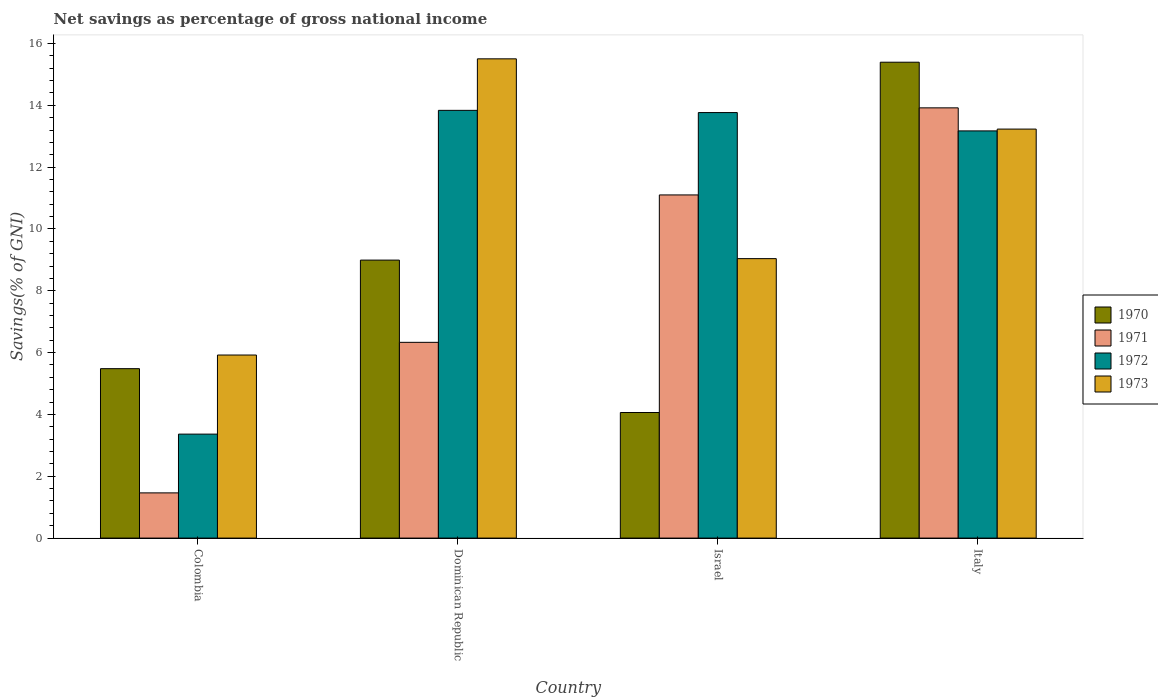How many different coloured bars are there?
Offer a terse response. 4. Are the number of bars per tick equal to the number of legend labels?
Provide a succinct answer. Yes. How many bars are there on the 2nd tick from the left?
Keep it short and to the point. 4. What is the total savings in 1973 in Israel?
Keep it short and to the point. 9.04. Across all countries, what is the maximum total savings in 1972?
Provide a succinct answer. 13.84. Across all countries, what is the minimum total savings in 1972?
Offer a very short reply. 3.36. In which country was the total savings in 1970 maximum?
Your answer should be very brief. Italy. What is the total total savings in 1970 in the graph?
Keep it short and to the point. 33.93. What is the difference between the total savings in 1973 in Colombia and that in Italy?
Make the answer very short. -7.31. What is the difference between the total savings in 1970 in Colombia and the total savings in 1972 in Italy?
Ensure brevity in your answer.  -7.69. What is the average total savings in 1972 per country?
Your answer should be compact. 11.04. What is the difference between the total savings of/in 1972 and total savings of/in 1973 in Dominican Republic?
Ensure brevity in your answer.  -1.67. What is the ratio of the total savings in 1972 in Colombia to that in Dominican Republic?
Keep it short and to the point. 0.24. Is the difference between the total savings in 1972 in Dominican Republic and Israel greater than the difference between the total savings in 1973 in Dominican Republic and Israel?
Your answer should be compact. No. What is the difference between the highest and the second highest total savings in 1970?
Offer a terse response. 3.51. What is the difference between the highest and the lowest total savings in 1970?
Ensure brevity in your answer.  11.33. In how many countries, is the total savings in 1972 greater than the average total savings in 1972 taken over all countries?
Give a very brief answer. 3. What does the 3rd bar from the left in Israel represents?
Your answer should be very brief. 1972. What does the 2nd bar from the right in Dominican Republic represents?
Offer a very short reply. 1972. Is it the case that in every country, the sum of the total savings in 1970 and total savings in 1971 is greater than the total savings in 1972?
Your answer should be compact. Yes. Are all the bars in the graph horizontal?
Offer a terse response. No. Are the values on the major ticks of Y-axis written in scientific E-notation?
Provide a short and direct response. No. Where does the legend appear in the graph?
Make the answer very short. Center right. How are the legend labels stacked?
Keep it short and to the point. Vertical. What is the title of the graph?
Keep it short and to the point. Net savings as percentage of gross national income. Does "2014" appear as one of the legend labels in the graph?
Your answer should be very brief. No. What is the label or title of the X-axis?
Give a very brief answer. Country. What is the label or title of the Y-axis?
Your answer should be compact. Savings(% of GNI). What is the Savings(% of GNI) of 1970 in Colombia?
Your answer should be very brief. 5.48. What is the Savings(% of GNI) in 1971 in Colombia?
Your response must be concise. 1.46. What is the Savings(% of GNI) in 1972 in Colombia?
Keep it short and to the point. 3.36. What is the Savings(% of GNI) in 1973 in Colombia?
Give a very brief answer. 5.92. What is the Savings(% of GNI) of 1970 in Dominican Republic?
Provide a short and direct response. 8.99. What is the Savings(% of GNI) of 1971 in Dominican Republic?
Your answer should be very brief. 6.33. What is the Savings(% of GNI) of 1972 in Dominican Republic?
Your answer should be compact. 13.84. What is the Savings(% of GNI) of 1973 in Dominican Republic?
Offer a very short reply. 15.5. What is the Savings(% of GNI) of 1970 in Israel?
Your answer should be compact. 4.06. What is the Savings(% of GNI) of 1971 in Israel?
Make the answer very short. 11.1. What is the Savings(% of GNI) in 1972 in Israel?
Ensure brevity in your answer.  13.77. What is the Savings(% of GNI) of 1973 in Israel?
Provide a succinct answer. 9.04. What is the Savings(% of GNI) in 1970 in Italy?
Keep it short and to the point. 15.4. What is the Savings(% of GNI) in 1971 in Italy?
Your answer should be compact. 13.92. What is the Savings(% of GNI) in 1972 in Italy?
Your answer should be compact. 13.17. What is the Savings(% of GNI) in 1973 in Italy?
Provide a succinct answer. 13.23. Across all countries, what is the maximum Savings(% of GNI) of 1970?
Ensure brevity in your answer.  15.4. Across all countries, what is the maximum Savings(% of GNI) of 1971?
Provide a short and direct response. 13.92. Across all countries, what is the maximum Savings(% of GNI) in 1972?
Provide a short and direct response. 13.84. Across all countries, what is the maximum Savings(% of GNI) in 1973?
Your answer should be compact. 15.5. Across all countries, what is the minimum Savings(% of GNI) of 1970?
Provide a short and direct response. 4.06. Across all countries, what is the minimum Savings(% of GNI) in 1971?
Provide a succinct answer. 1.46. Across all countries, what is the minimum Savings(% of GNI) in 1972?
Make the answer very short. 3.36. Across all countries, what is the minimum Savings(% of GNI) in 1973?
Ensure brevity in your answer.  5.92. What is the total Savings(% of GNI) of 1970 in the graph?
Provide a succinct answer. 33.93. What is the total Savings(% of GNI) of 1971 in the graph?
Keep it short and to the point. 32.82. What is the total Savings(% of GNI) in 1972 in the graph?
Your answer should be very brief. 44.14. What is the total Savings(% of GNI) of 1973 in the graph?
Your answer should be compact. 43.7. What is the difference between the Savings(% of GNI) in 1970 in Colombia and that in Dominican Republic?
Offer a very short reply. -3.51. What is the difference between the Savings(% of GNI) of 1971 in Colombia and that in Dominican Republic?
Your answer should be compact. -4.87. What is the difference between the Savings(% of GNI) in 1972 in Colombia and that in Dominican Republic?
Give a very brief answer. -10.47. What is the difference between the Savings(% of GNI) in 1973 in Colombia and that in Dominican Republic?
Your answer should be very brief. -9.58. What is the difference between the Savings(% of GNI) of 1970 in Colombia and that in Israel?
Your answer should be very brief. 1.42. What is the difference between the Savings(% of GNI) in 1971 in Colombia and that in Israel?
Give a very brief answer. -9.64. What is the difference between the Savings(% of GNI) of 1972 in Colombia and that in Israel?
Provide a succinct answer. -10.4. What is the difference between the Savings(% of GNI) in 1973 in Colombia and that in Israel?
Provide a short and direct response. -3.12. What is the difference between the Savings(% of GNI) of 1970 in Colombia and that in Italy?
Keep it short and to the point. -9.91. What is the difference between the Savings(% of GNI) of 1971 in Colombia and that in Italy?
Your answer should be very brief. -12.46. What is the difference between the Savings(% of GNI) of 1972 in Colombia and that in Italy?
Make the answer very short. -9.81. What is the difference between the Savings(% of GNI) in 1973 in Colombia and that in Italy?
Provide a short and direct response. -7.31. What is the difference between the Savings(% of GNI) of 1970 in Dominican Republic and that in Israel?
Ensure brevity in your answer.  4.93. What is the difference between the Savings(% of GNI) of 1971 in Dominican Republic and that in Israel?
Ensure brevity in your answer.  -4.77. What is the difference between the Savings(% of GNI) of 1972 in Dominican Republic and that in Israel?
Your response must be concise. 0.07. What is the difference between the Savings(% of GNI) in 1973 in Dominican Republic and that in Israel?
Ensure brevity in your answer.  6.46. What is the difference between the Savings(% of GNI) in 1970 in Dominican Republic and that in Italy?
Make the answer very short. -6.4. What is the difference between the Savings(% of GNI) of 1971 in Dominican Republic and that in Italy?
Offer a very short reply. -7.59. What is the difference between the Savings(% of GNI) of 1972 in Dominican Republic and that in Italy?
Keep it short and to the point. 0.66. What is the difference between the Savings(% of GNI) in 1973 in Dominican Republic and that in Italy?
Offer a very short reply. 2.27. What is the difference between the Savings(% of GNI) in 1970 in Israel and that in Italy?
Provide a succinct answer. -11.33. What is the difference between the Savings(% of GNI) of 1971 in Israel and that in Italy?
Offer a very short reply. -2.82. What is the difference between the Savings(% of GNI) in 1972 in Israel and that in Italy?
Make the answer very short. 0.59. What is the difference between the Savings(% of GNI) of 1973 in Israel and that in Italy?
Your response must be concise. -4.19. What is the difference between the Savings(% of GNI) in 1970 in Colombia and the Savings(% of GNI) in 1971 in Dominican Republic?
Provide a succinct answer. -0.85. What is the difference between the Savings(% of GNI) in 1970 in Colombia and the Savings(% of GNI) in 1972 in Dominican Republic?
Your answer should be compact. -8.36. What is the difference between the Savings(% of GNI) of 1970 in Colombia and the Savings(% of GNI) of 1973 in Dominican Republic?
Your answer should be very brief. -10.02. What is the difference between the Savings(% of GNI) of 1971 in Colombia and the Savings(% of GNI) of 1972 in Dominican Republic?
Give a very brief answer. -12.38. What is the difference between the Savings(% of GNI) of 1971 in Colombia and the Savings(% of GNI) of 1973 in Dominican Republic?
Offer a very short reply. -14.04. What is the difference between the Savings(% of GNI) of 1972 in Colombia and the Savings(% of GNI) of 1973 in Dominican Republic?
Ensure brevity in your answer.  -12.14. What is the difference between the Savings(% of GNI) in 1970 in Colombia and the Savings(% of GNI) in 1971 in Israel?
Ensure brevity in your answer.  -5.62. What is the difference between the Savings(% of GNI) in 1970 in Colombia and the Savings(% of GNI) in 1972 in Israel?
Your answer should be compact. -8.28. What is the difference between the Savings(% of GNI) in 1970 in Colombia and the Savings(% of GNI) in 1973 in Israel?
Ensure brevity in your answer.  -3.56. What is the difference between the Savings(% of GNI) of 1971 in Colombia and the Savings(% of GNI) of 1972 in Israel?
Keep it short and to the point. -12.3. What is the difference between the Savings(% of GNI) in 1971 in Colombia and the Savings(% of GNI) in 1973 in Israel?
Offer a very short reply. -7.58. What is the difference between the Savings(% of GNI) of 1972 in Colombia and the Savings(% of GNI) of 1973 in Israel?
Offer a terse response. -5.68. What is the difference between the Savings(% of GNI) in 1970 in Colombia and the Savings(% of GNI) in 1971 in Italy?
Your response must be concise. -8.44. What is the difference between the Savings(% of GNI) in 1970 in Colombia and the Savings(% of GNI) in 1972 in Italy?
Your answer should be compact. -7.69. What is the difference between the Savings(% of GNI) in 1970 in Colombia and the Savings(% of GNI) in 1973 in Italy?
Your answer should be very brief. -7.75. What is the difference between the Savings(% of GNI) of 1971 in Colombia and the Savings(% of GNI) of 1972 in Italy?
Give a very brief answer. -11.71. What is the difference between the Savings(% of GNI) of 1971 in Colombia and the Savings(% of GNI) of 1973 in Italy?
Ensure brevity in your answer.  -11.77. What is the difference between the Savings(% of GNI) in 1972 in Colombia and the Savings(% of GNI) in 1973 in Italy?
Give a very brief answer. -9.87. What is the difference between the Savings(% of GNI) in 1970 in Dominican Republic and the Savings(% of GNI) in 1971 in Israel?
Offer a terse response. -2.11. What is the difference between the Savings(% of GNI) of 1970 in Dominican Republic and the Savings(% of GNI) of 1972 in Israel?
Your answer should be compact. -4.77. What is the difference between the Savings(% of GNI) of 1970 in Dominican Republic and the Savings(% of GNI) of 1973 in Israel?
Offer a terse response. -0.05. What is the difference between the Savings(% of GNI) in 1971 in Dominican Republic and the Savings(% of GNI) in 1972 in Israel?
Make the answer very short. -7.43. What is the difference between the Savings(% of GNI) in 1971 in Dominican Republic and the Savings(% of GNI) in 1973 in Israel?
Ensure brevity in your answer.  -2.71. What is the difference between the Savings(% of GNI) of 1972 in Dominican Republic and the Savings(% of GNI) of 1973 in Israel?
Ensure brevity in your answer.  4.8. What is the difference between the Savings(% of GNI) of 1970 in Dominican Republic and the Savings(% of GNI) of 1971 in Italy?
Your answer should be very brief. -4.93. What is the difference between the Savings(% of GNI) of 1970 in Dominican Republic and the Savings(% of GNI) of 1972 in Italy?
Ensure brevity in your answer.  -4.18. What is the difference between the Savings(% of GNI) in 1970 in Dominican Republic and the Savings(% of GNI) in 1973 in Italy?
Provide a short and direct response. -4.24. What is the difference between the Savings(% of GNI) in 1971 in Dominican Republic and the Savings(% of GNI) in 1972 in Italy?
Offer a terse response. -6.84. What is the difference between the Savings(% of GNI) in 1971 in Dominican Republic and the Savings(% of GNI) in 1973 in Italy?
Offer a very short reply. -6.9. What is the difference between the Savings(% of GNI) in 1972 in Dominican Republic and the Savings(% of GNI) in 1973 in Italy?
Your answer should be compact. 0.61. What is the difference between the Savings(% of GNI) of 1970 in Israel and the Savings(% of GNI) of 1971 in Italy?
Give a very brief answer. -9.86. What is the difference between the Savings(% of GNI) of 1970 in Israel and the Savings(% of GNI) of 1972 in Italy?
Give a very brief answer. -9.11. What is the difference between the Savings(% of GNI) of 1970 in Israel and the Savings(% of GNI) of 1973 in Italy?
Your response must be concise. -9.17. What is the difference between the Savings(% of GNI) in 1971 in Israel and the Savings(% of GNI) in 1972 in Italy?
Keep it short and to the point. -2.07. What is the difference between the Savings(% of GNI) of 1971 in Israel and the Savings(% of GNI) of 1973 in Italy?
Offer a terse response. -2.13. What is the difference between the Savings(% of GNI) of 1972 in Israel and the Savings(% of GNI) of 1973 in Italy?
Keep it short and to the point. 0.53. What is the average Savings(% of GNI) in 1970 per country?
Provide a succinct answer. 8.48. What is the average Savings(% of GNI) of 1971 per country?
Your answer should be compact. 8.2. What is the average Savings(% of GNI) in 1972 per country?
Offer a terse response. 11.04. What is the average Savings(% of GNI) of 1973 per country?
Offer a very short reply. 10.93. What is the difference between the Savings(% of GNI) of 1970 and Savings(% of GNI) of 1971 in Colombia?
Ensure brevity in your answer.  4.02. What is the difference between the Savings(% of GNI) of 1970 and Savings(% of GNI) of 1972 in Colombia?
Your answer should be very brief. 2.12. What is the difference between the Savings(% of GNI) in 1970 and Savings(% of GNI) in 1973 in Colombia?
Give a very brief answer. -0.44. What is the difference between the Savings(% of GNI) of 1971 and Savings(% of GNI) of 1972 in Colombia?
Make the answer very short. -1.9. What is the difference between the Savings(% of GNI) in 1971 and Savings(% of GNI) in 1973 in Colombia?
Your answer should be compact. -4.46. What is the difference between the Savings(% of GNI) in 1972 and Savings(% of GNI) in 1973 in Colombia?
Offer a terse response. -2.56. What is the difference between the Savings(% of GNI) in 1970 and Savings(% of GNI) in 1971 in Dominican Republic?
Provide a succinct answer. 2.66. What is the difference between the Savings(% of GNI) of 1970 and Savings(% of GNI) of 1972 in Dominican Republic?
Keep it short and to the point. -4.84. What is the difference between the Savings(% of GNI) in 1970 and Savings(% of GNI) in 1973 in Dominican Republic?
Your answer should be compact. -6.51. What is the difference between the Savings(% of GNI) of 1971 and Savings(% of GNI) of 1972 in Dominican Republic?
Provide a short and direct response. -7.5. What is the difference between the Savings(% of GNI) in 1971 and Savings(% of GNI) in 1973 in Dominican Republic?
Make the answer very short. -9.17. What is the difference between the Savings(% of GNI) in 1972 and Savings(% of GNI) in 1973 in Dominican Republic?
Ensure brevity in your answer.  -1.67. What is the difference between the Savings(% of GNI) in 1970 and Savings(% of GNI) in 1971 in Israel?
Provide a succinct answer. -7.04. What is the difference between the Savings(% of GNI) in 1970 and Savings(% of GNI) in 1972 in Israel?
Offer a terse response. -9.7. What is the difference between the Savings(% of GNI) in 1970 and Savings(% of GNI) in 1973 in Israel?
Provide a short and direct response. -4.98. What is the difference between the Savings(% of GNI) of 1971 and Savings(% of GNI) of 1972 in Israel?
Provide a short and direct response. -2.66. What is the difference between the Savings(% of GNI) of 1971 and Savings(% of GNI) of 1973 in Israel?
Keep it short and to the point. 2.06. What is the difference between the Savings(% of GNI) in 1972 and Savings(% of GNI) in 1973 in Israel?
Give a very brief answer. 4.73. What is the difference between the Savings(% of GNI) in 1970 and Savings(% of GNI) in 1971 in Italy?
Your response must be concise. 1.48. What is the difference between the Savings(% of GNI) in 1970 and Savings(% of GNI) in 1972 in Italy?
Your response must be concise. 2.22. What is the difference between the Savings(% of GNI) of 1970 and Savings(% of GNI) of 1973 in Italy?
Offer a terse response. 2.16. What is the difference between the Savings(% of GNI) of 1971 and Savings(% of GNI) of 1972 in Italy?
Your answer should be very brief. 0.75. What is the difference between the Savings(% of GNI) of 1971 and Savings(% of GNI) of 1973 in Italy?
Provide a short and direct response. 0.69. What is the difference between the Savings(% of GNI) of 1972 and Savings(% of GNI) of 1973 in Italy?
Keep it short and to the point. -0.06. What is the ratio of the Savings(% of GNI) in 1970 in Colombia to that in Dominican Republic?
Your answer should be very brief. 0.61. What is the ratio of the Savings(% of GNI) in 1971 in Colombia to that in Dominican Republic?
Your response must be concise. 0.23. What is the ratio of the Savings(% of GNI) of 1972 in Colombia to that in Dominican Republic?
Keep it short and to the point. 0.24. What is the ratio of the Savings(% of GNI) of 1973 in Colombia to that in Dominican Republic?
Give a very brief answer. 0.38. What is the ratio of the Savings(% of GNI) in 1970 in Colombia to that in Israel?
Provide a short and direct response. 1.35. What is the ratio of the Savings(% of GNI) in 1971 in Colombia to that in Israel?
Your response must be concise. 0.13. What is the ratio of the Savings(% of GNI) in 1972 in Colombia to that in Israel?
Keep it short and to the point. 0.24. What is the ratio of the Savings(% of GNI) of 1973 in Colombia to that in Israel?
Make the answer very short. 0.66. What is the ratio of the Savings(% of GNI) of 1970 in Colombia to that in Italy?
Your answer should be very brief. 0.36. What is the ratio of the Savings(% of GNI) of 1971 in Colombia to that in Italy?
Your response must be concise. 0.11. What is the ratio of the Savings(% of GNI) of 1972 in Colombia to that in Italy?
Your response must be concise. 0.26. What is the ratio of the Savings(% of GNI) in 1973 in Colombia to that in Italy?
Your answer should be very brief. 0.45. What is the ratio of the Savings(% of GNI) in 1970 in Dominican Republic to that in Israel?
Offer a very short reply. 2.21. What is the ratio of the Savings(% of GNI) of 1971 in Dominican Republic to that in Israel?
Your response must be concise. 0.57. What is the ratio of the Savings(% of GNI) in 1972 in Dominican Republic to that in Israel?
Your answer should be very brief. 1.01. What is the ratio of the Savings(% of GNI) in 1973 in Dominican Republic to that in Israel?
Your response must be concise. 1.71. What is the ratio of the Savings(% of GNI) of 1970 in Dominican Republic to that in Italy?
Keep it short and to the point. 0.58. What is the ratio of the Savings(% of GNI) in 1971 in Dominican Republic to that in Italy?
Your answer should be very brief. 0.46. What is the ratio of the Savings(% of GNI) in 1972 in Dominican Republic to that in Italy?
Keep it short and to the point. 1.05. What is the ratio of the Savings(% of GNI) of 1973 in Dominican Republic to that in Italy?
Provide a short and direct response. 1.17. What is the ratio of the Savings(% of GNI) in 1970 in Israel to that in Italy?
Your answer should be compact. 0.26. What is the ratio of the Savings(% of GNI) in 1971 in Israel to that in Italy?
Your response must be concise. 0.8. What is the ratio of the Savings(% of GNI) of 1972 in Israel to that in Italy?
Ensure brevity in your answer.  1.04. What is the ratio of the Savings(% of GNI) in 1973 in Israel to that in Italy?
Your answer should be compact. 0.68. What is the difference between the highest and the second highest Savings(% of GNI) in 1970?
Your answer should be very brief. 6.4. What is the difference between the highest and the second highest Savings(% of GNI) in 1971?
Your answer should be compact. 2.82. What is the difference between the highest and the second highest Savings(% of GNI) in 1972?
Your answer should be very brief. 0.07. What is the difference between the highest and the second highest Savings(% of GNI) in 1973?
Your answer should be very brief. 2.27. What is the difference between the highest and the lowest Savings(% of GNI) in 1970?
Your answer should be compact. 11.33. What is the difference between the highest and the lowest Savings(% of GNI) in 1971?
Offer a terse response. 12.46. What is the difference between the highest and the lowest Savings(% of GNI) of 1972?
Offer a very short reply. 10.47. What is the difference between the highest and the lowest Savings(% of GNI) in 1973?
Offer a very short reply. 9.58. 